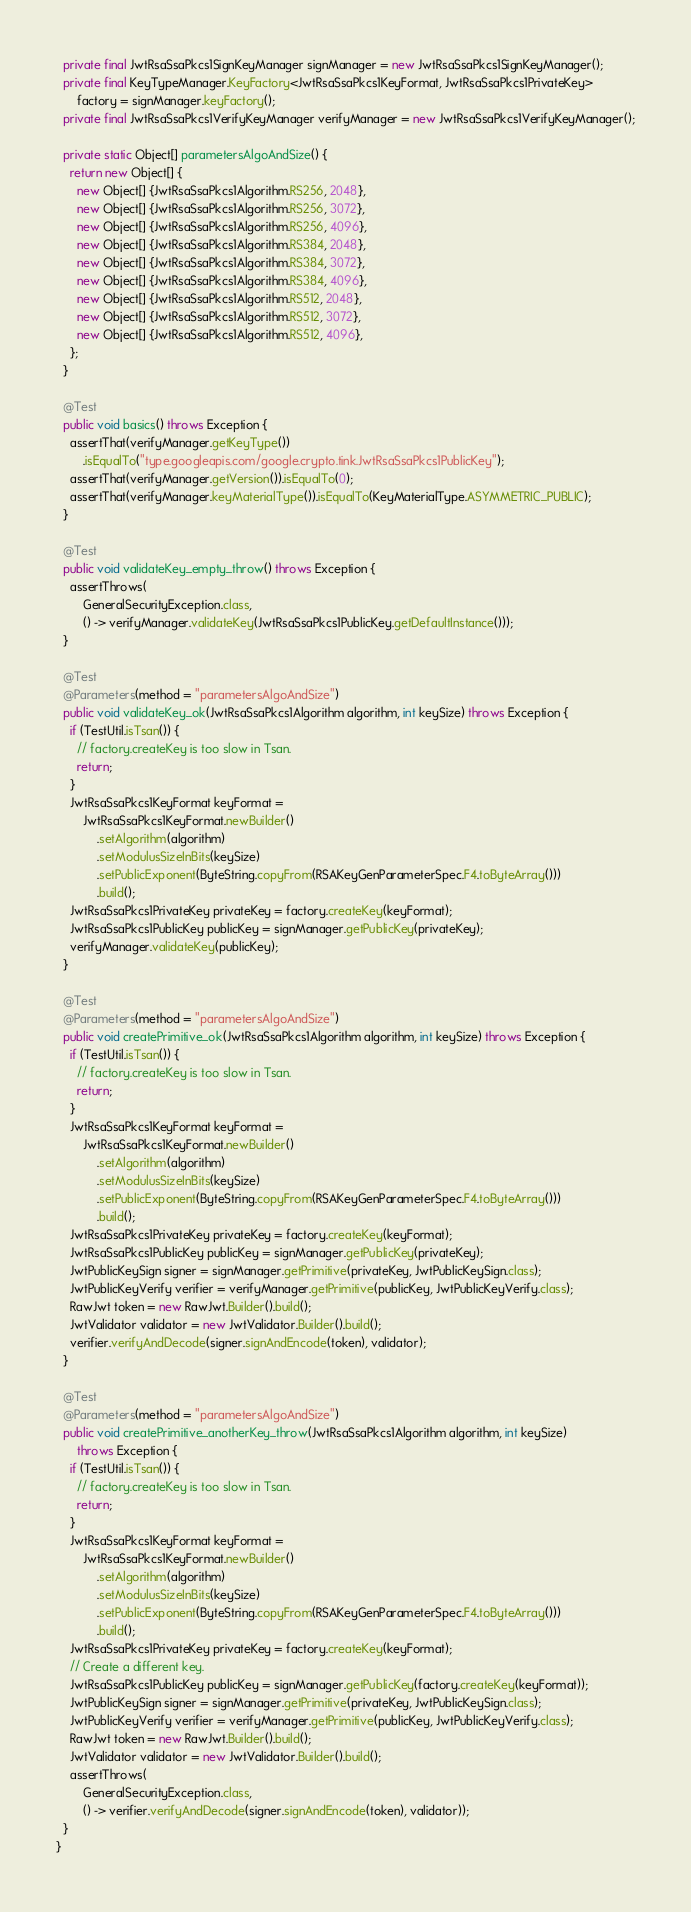<code> <loc_0><loc_0><loc_500><loc_500><_Java_>  private final JwtRsaSsaPkcs1SignKeyManager signManager = new JwtRsaSsaPkcs1SignKeyManager();
  private final KeyTypeManager.KeyFactory<JwtRsaSsaPkcs1KeyFormat, JwtRsaSsaPkcs1PrivateKey>
      factory = signManager.keyFactory();
  private final JwtRsaSsaPkcs1VerifyKeyManager verifyManager = new JwtRsaSsaPkcs1VerifyKeyManager();

  private static Object[] parametersAlgoAndSize() {
    return new Object[] {
      new Object[] {JwtRsaSsaPkcs1Algorithm.RS256, 2048},
      new Object[] {JwtRsaSsaPkcs1Algorithm.RS256, 3072},
      new Object[] {JwtRsaSsaPkcs1Algorithm.RS256, 4096},
      new Object[] {JwtRsaSsaPkcs1Algorithm.RS384, 2048},
      new Object[] {JwtRsaSsaPkcs1Algorithm.RS384, 3072},
      new Object[] {JwtRsaSsaPkcs1Algorithm.RS384, 4096},
      new Object[] {JwtRsaSsaPkcs1Algorithm.RS512, 2048},
      new Object[] {JwtRsaSsaPkcs1Algorithm.RS512, 3072},
      new Object[] {JwtRsaSsaPkcs1Algorithm.RS512, 4096},
    };
  }

  @Test
  public void basics() throws Exception {
    assertThat(verifyManager.getKeyType())
        .isEqualTo("type.googleapis.com/google.crypto.tink.JwtRsaSsaPkcs1PublicKey");
    assertThat(verifyManager.getVersion()).isEqualTo(0);
    assertThat(verifyManager.keyMaterialType()).isEqualTo(KeyMaterialType.ASYMMETRIC_PUBLIC);
  }

  @Test
  public void validateKey_empty_throw() throws Exception {
    assertThrows(
        GeneralSecurityException.class,
        () -> verifyManager.validateKey(JwtRsaSsaPkcs1PublicKey.getDefaultInstance()));
  }

  @Test
  @Parameters(method = "parametersAlgoAndSize")
  public void validateKey_ok(JwtRsaSsaPkcs1Algorithm algorithm, int keySize) throws Exception {
    if (TestUtil.isTsan()) {
      // factory.createKey is too slow in Tsan.
      return;
    }
    JwtRsaSsaPkcs1KeyFormat keyFormat =
        JwtRsaSsaPkcs1KeyFormat.newBuilder()
            .setAlgorithm(algorithm)
            .setModulusSizeInBits(keySize)
            .setPublicExponent(ByteString.copyFrom(RSAKeyGenParameterSpec.F4.toByteArray()))
            .build();
    JwtRsaSsaPkcs1PrivateKey privateKey = factory.createKey(keyFormat);
    JwtRsaSsaPkcs1PublicKey publicKey = signManager.getPublicKey(privateKey);
    verifyManager.validateKey(publicKey);
  }

  @Test
  @Parameters(method = "parametersAlgoAndSize")
  public void createPrimitive_ok(JwtRsaSsaPkcs1Algorithm algorithm, int keySize) throws Exception {
    if (TestUtil.isTsan()) {
      // factory.createKey is too slow in Tsan.
      return;
    }
    JwtRsaSsaPkcs1KeyFormat keyFormat =
        JwtRsaSsaPkcs1KeyFormat.newBuilder()
            .setAlgorithm(algorithm)
            .setModulusSizeInBits(keySize)
            .setPublicExponent(ByteString.copyFrom(RSAKeyGenParameterSpec.F4.toByteArray()))
            .build();
    JwtRsaSsaPkcs1PrivateKey privateKey = factory.createKey(keyFormat);
    JwtRsaSsaPkcs1PublicKey publicKey = signManager.getPublicKey(privateKey);
    JwtPublicKeySign signer = signManager.getPrimitive(privateKey, JwtPublicKeySign.class);
    JwtPublicKeyVerify verifier = verifyManager.getPrimitive(publicKey, JwtPublicKeyVerify.class);
    RawJwt token = new RawJwt.Builder().build();
    JwtValidator validator = new JwtValidator.Builder().build();
    verifier.verifyAndDecode(signer.signAndEncode(token), validator);
  }

  @Test
  @Parameters(method = "parametersAlgoAndSize")
  public void createPrimitive_anotherKey_throw(JwtRsaSsaPkcs1Algorithm algorithm, int keySize)
      throws Exception {
    if (TestUtil.isTsan()) {
      // factory.createKey is too slow in Tsan.
      return;
    }
    JwtRsaSsaPkcs1KeyFormat keyFormat =
        JwtRsaSsaPkcs1KeyFormat.newBuilder()
            .setAlgorithm(algorithm)
            .setModulusSizeInBits(keySize)
            .setPublicExponent(ByteString.copyFrom(RSAKeyGenParameterSpec.F4.toByteArray()))
            .build();
    JwtRsaSsaPkcs1PrivateKey privateKey = factory.createKey(keyFormat);
    // Create a different key.
    JwtRsaSsaPkcs1PublicKey publicKey = signManager.getPublicKey(factory.createKey(keyFormat));
    JwtPublicKeySign signer = signManager.getPrimitive(privateKey, JwtPublicKeySign.class);
    JwtPublicKeyVerify verifier = verifyManager.getPrimitive(publicKey, JwtPublicKeyVerify.class);
    RawJwt token = new RawJwt.Builder().build();
    JwtValidator validator = new JwtValidator.Builder().build();
    assertThrows(
        GeneralSecurityException.class,
        () -> verifier.verifyAndDecode(signer.signAndEncode(token), validator));
  }
}
</code> 